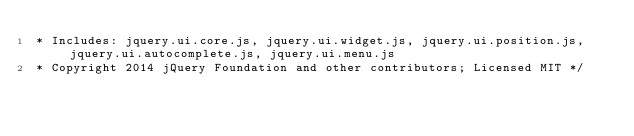Convert code to text. <code><loc_0><loc_0><loc_500><loc_500><_JavaScript_>* Includes: jquery.ui.core.js, jquery.ui.widget.js, jquery.ui.position.js, jquery.ui.autocomplete.js, jquery.ui.menu.js
* Copyright 2014 jQuery Foundation and other contributors; Licensed MIT */</code> 